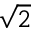Convert formula to latex. <formula><loc_0><loc_0><loc_500><loc_500>\sqrt { 2 }</formula> 